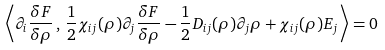<formula> <loc_0><loc_0><loc_500><loc_500>\left \langle \partial _ { i } \frac { \delta F } { \delta \rho } \, , \, \frac { 1 } { 2 } \chi _ { i j } ( \rho ) \partial _ { j } \frac { \delta F } { \delta \rho } - \frac { 1 } { 2 } D _ { i j } ( \rho ) \partial _ { j } \rho + \chi _ { i j } ( \rho ) E _ { j } \right \rangle = 0</formula> 